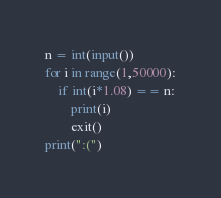<code> <loc_0><loc_0><loc_500><loc_500><_Python_>n = int(input())
for i in range(1,50000):
    if int(i*1.08) == n:
        print(i)
        exit()
print(":(")</code> 